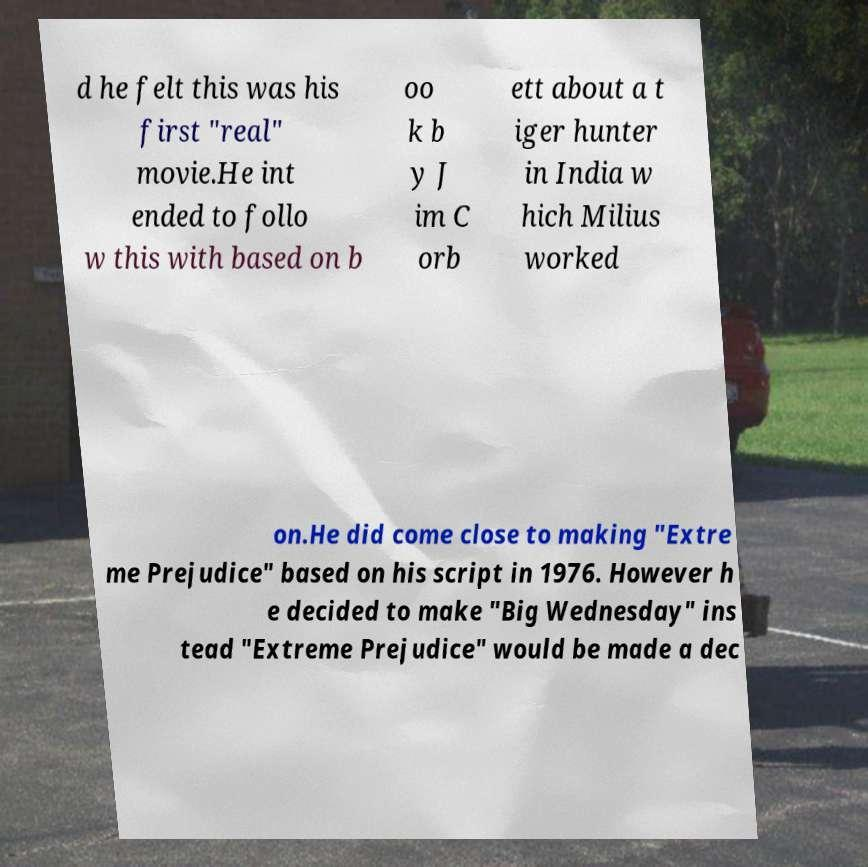I need the written content from this picture converted into text. Can you do that? d he felt this was his first "real" movie.He int ended to follo w this with based on b oo k b y J im C orb ett about a t iger hunter in India w hich Milius worked on.He did come close to making "Extre me Prejudice" based on his script in 1976. However h e decided to make "Big Wednesday" ins tead "Extreme Prejudice" would be made a dec 